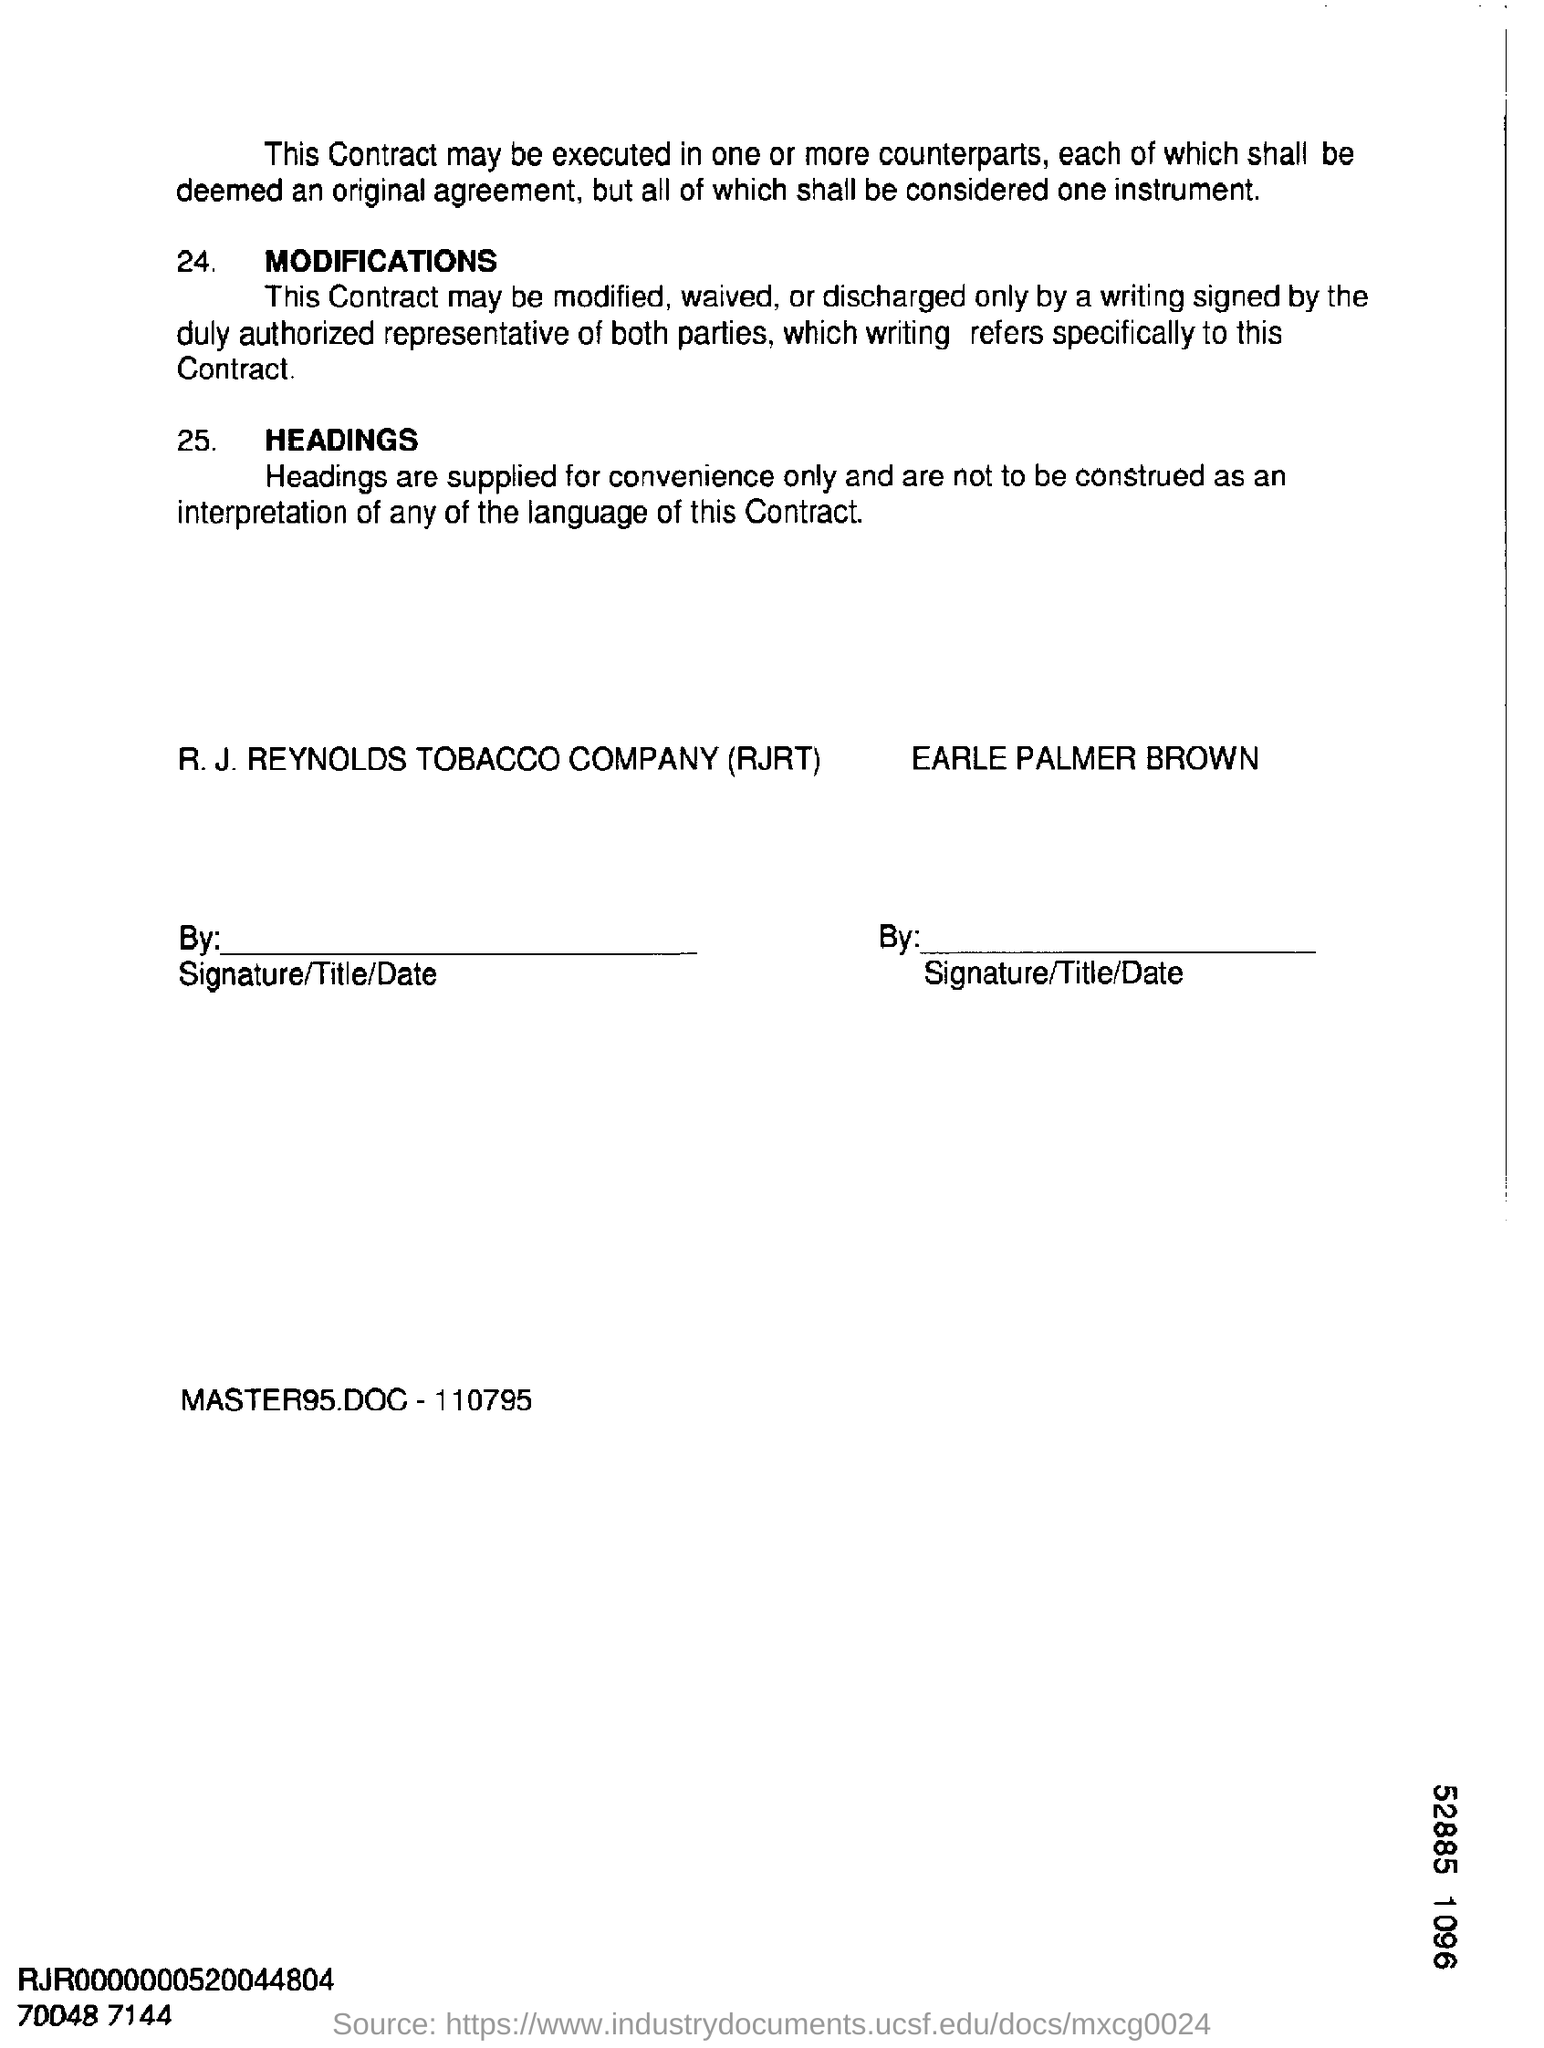What does rjrt stands for ?
Your response must be concise. R.J. Reynolds Tobacco Company. What is the master95doc number ?
Provide a succinct answer. 110795. 